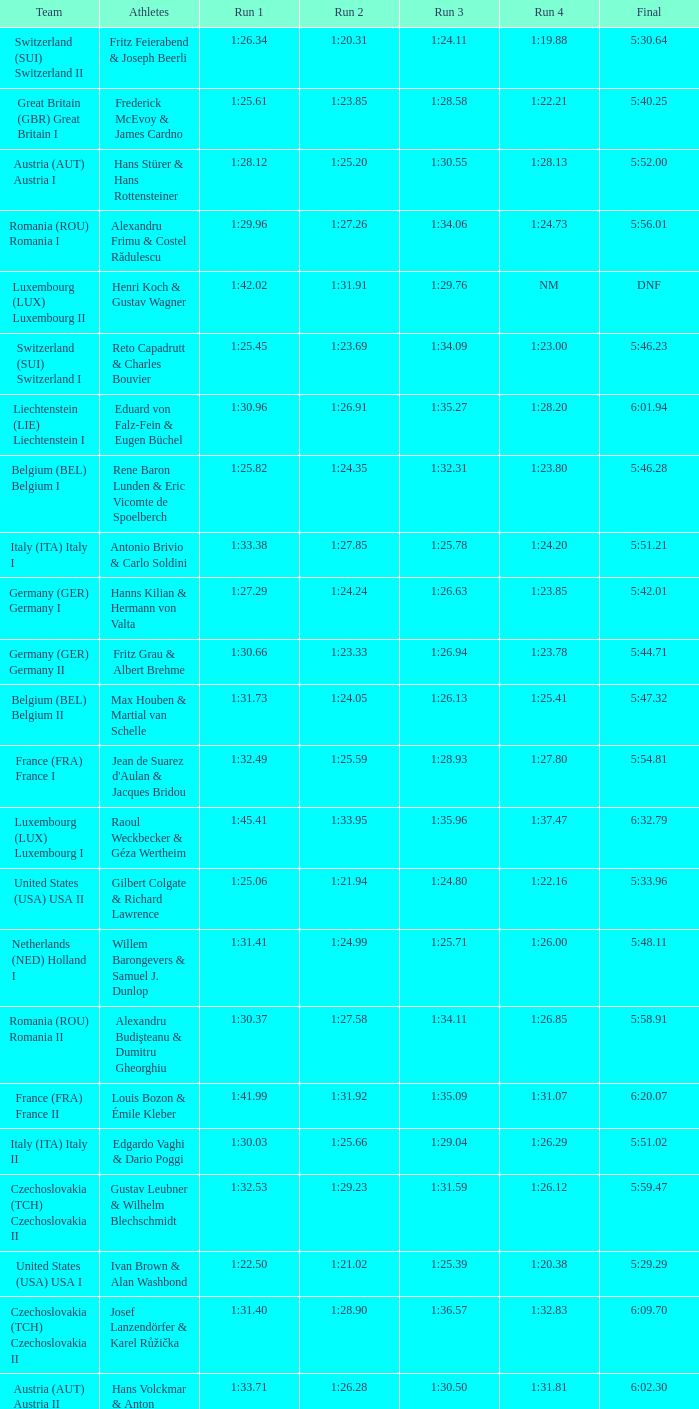Which Run 4 has a Run 1 of 1:25.82? 1:23.80. 